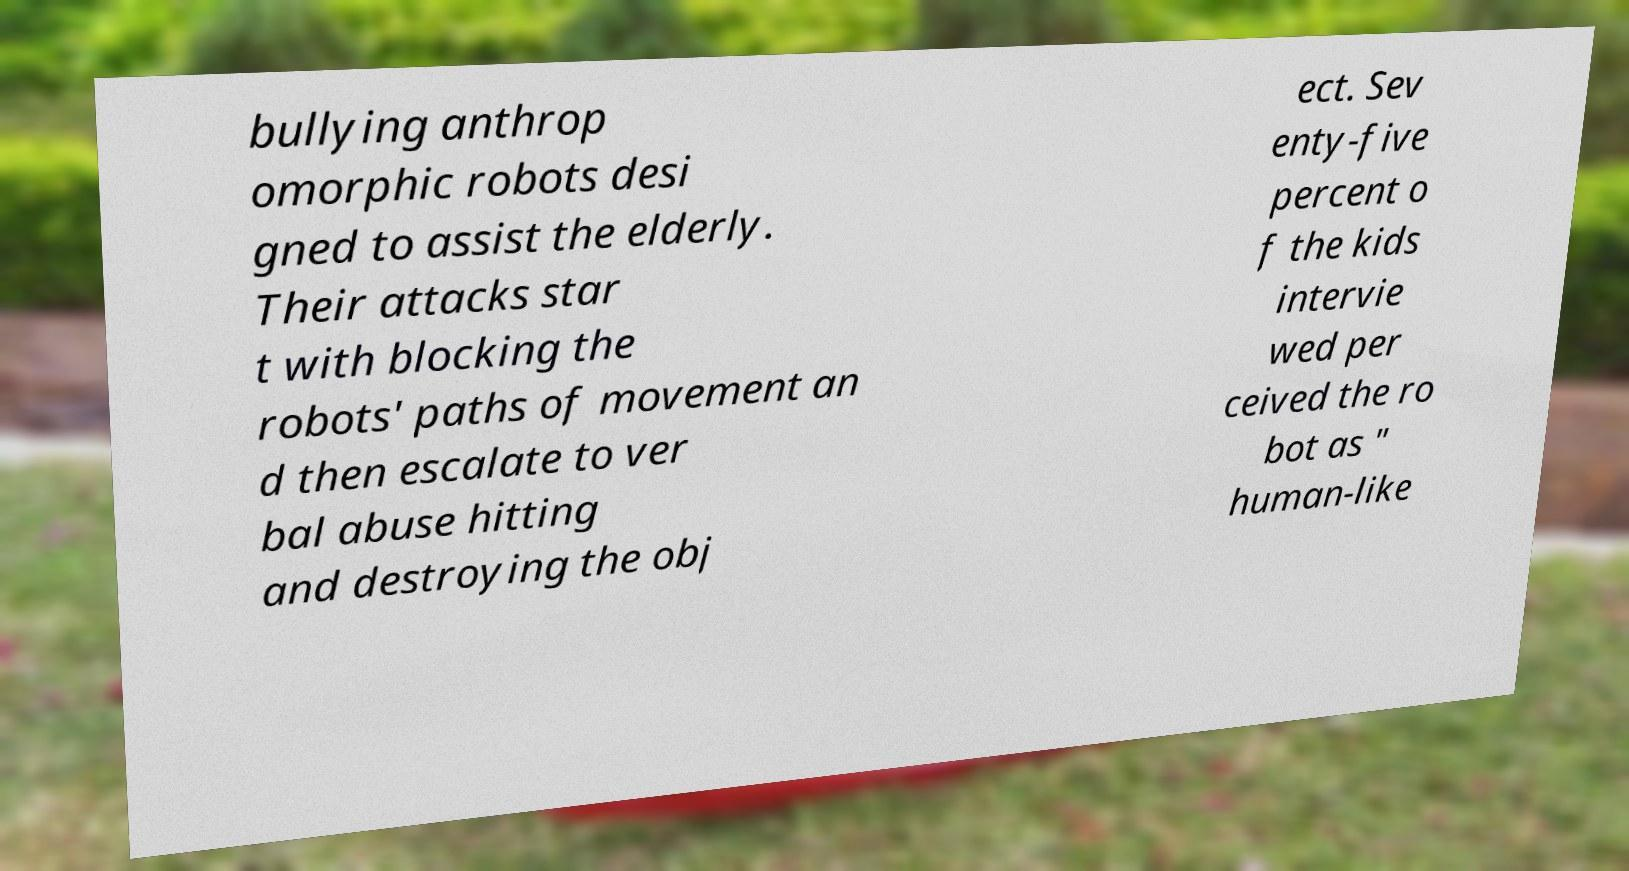Please identify and transcribe the text found in this image. bullying anthrop omorphic robots desi gned to assist the elderly. Their attacks star t with blocking the robots' paths of movement an d then escalate to ver bal abuse hitting and destroying the obj ect. Sev enty-five percent o f the kids intervie wed per ceived the ro bot as " human-like 